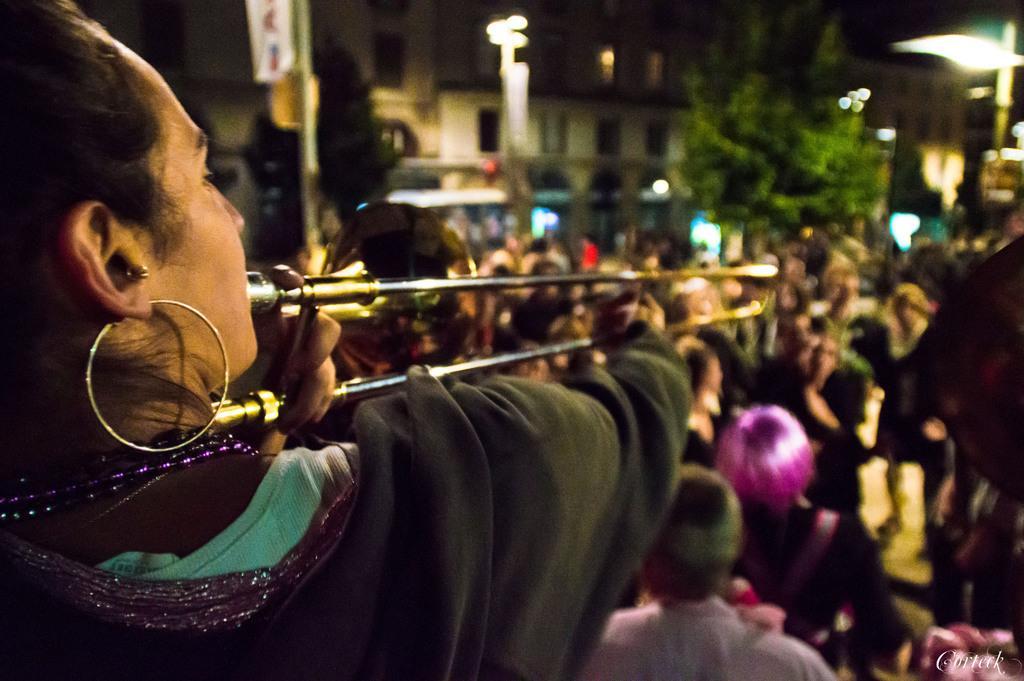Could you give a brief overview of what you see in this image? This is the picture of a person who is playing some musical instrument and around there are some people, buildings, poles which has some lights and boards. 